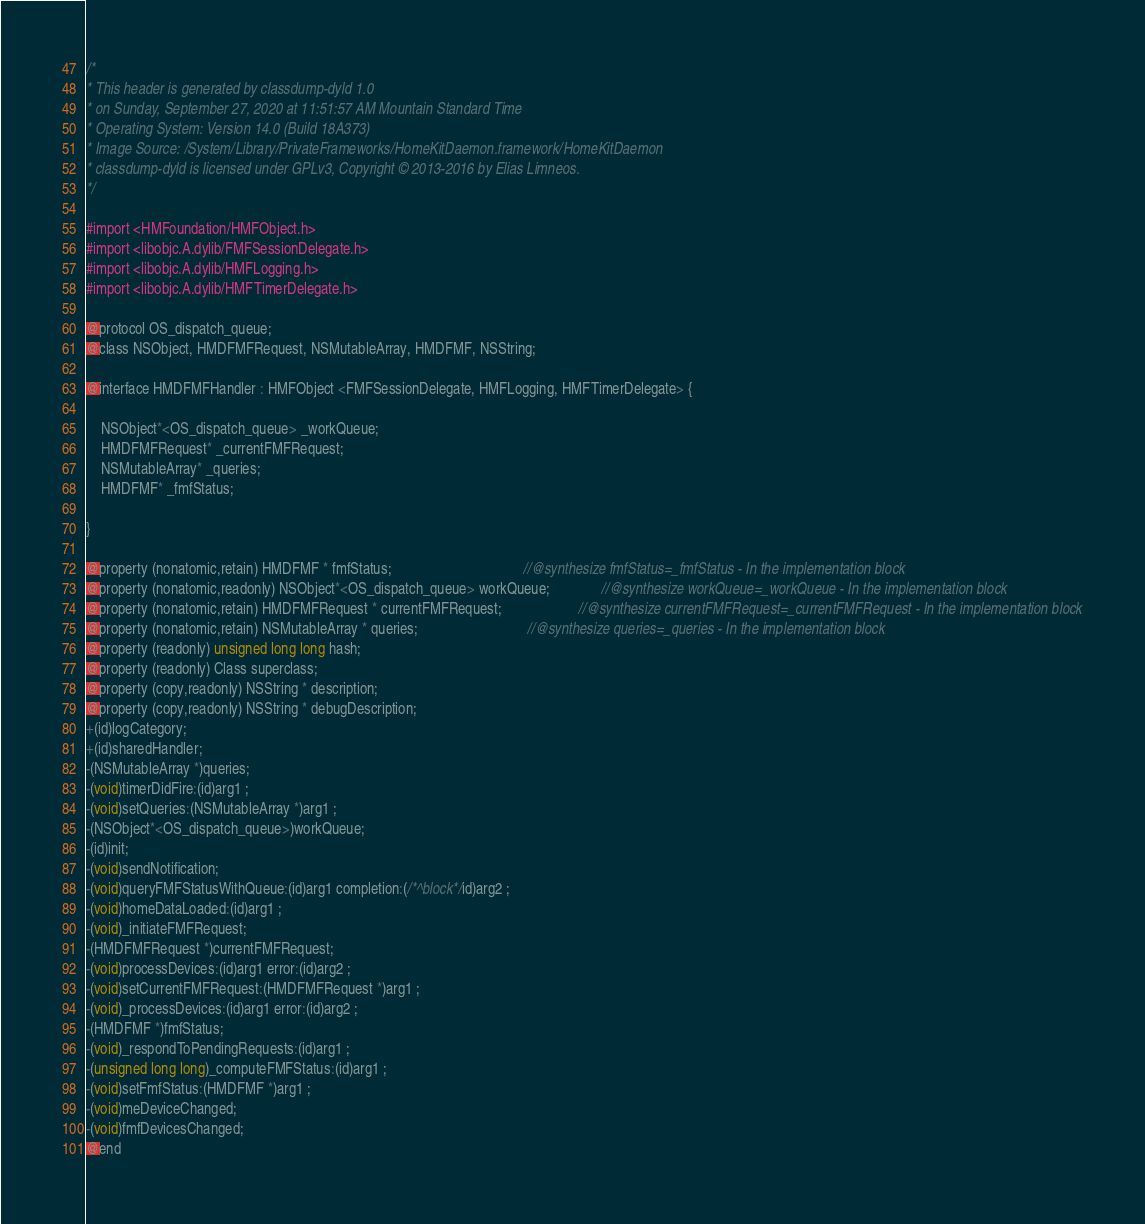<code> <loc_0><loc_0><loc_500><loc_500><_C_>/*
* This header is generated by classdump-dyld 1.0
* on Sunday, September 27, 2020 at 11:51:57 AM Mountain Standard Time
* Operating System: Version 14.0 (Build 18A373)
* Image Source: /System/Library/PrivateFrameworks/HomeKitDaemon.framework/HomeKitDaemon
* classdump-dyld is licensed under GPLv3, Copyright © 2013-2016 by Elias Limneos.
*/

#import <HMFoundation/HMFObject.h>
#import <libobjc.A.dylib/FMFSessionDelegate.h>
#import <libobjc.A.dylib/HMFLogging.h>
#import <libobjc.A.dylib/HMFTimerDelegate.h>

@protocol OS_dispatch_queue;
@class NSObject, HMDFMFRequest, NSMutableArray, HMDFMF, NSString;

@interface HMDFMFHandler : HMFObject <FMFSessionDelegate, HMFLogging, HMFTimerDelegate> {

	NSObject*<OS_dispatch_queue> _workQueue;
	HMDFMFRequest* _currentFMFRequest;
	NSMutableArray* _queries;
	HMDFMF* _fmfStatus;

}

@property (nonatomic,retain) HMDFMF * fmfStatus;                                    //@synthesize fmfStatus=_fmfStatus - In the implementation block
@property (nonatomic,readonly) NSObject*<OS_dispatch_queue> workQueue;              //@synthesize workQueue=_workQueue - In the implementation block
@property (nonatomic,retain) HMDFMFRequest * currentFMFRequest;                     //@synthesize currentFMFRequest=_currentFMFRequest - In the implementation block
@property (nonatomic,retain) NSMutableArray * queries;                              //@synthesize queries=_queries - In the implementation block
@property (readonly) unsigned long long hash; 
@property (readonly) Class superclass; 
@property (copy,readonly) NSString * description; 
@property (copy,readonly) NSString * debugDescription; 
+(id)logCategory;
+(id)sharedHandler;
-(NSMutableArray *)queries;
-(void)timerDidFire:(id)arg1 ;
-(void)setQueries:(NSMutableArray *)arg1 ;
-(NSObject*<OS_dispatch_queue>)workQueue;
-(id)init;
-(void)sendNotification;
-(void)queryFMFStatusWithQueue:(id)arg1 completion:(/*^block*/id)arg2 ;
-(void)homeDataLoaded:(id)arg1 ;
-(void)_initiateFMFRequest;
-(HMDFMFRequest *)currentFMFRequest;
-(void)processDevices:(id)arg1 error:(id)arg2 ;
-(void)setCurrentFMFRequest:(HMDFMFRequest *)arg1 ;
-(void)_processDevices:(id)arg1 error:(id)arg2 ;
-(HMDFMF *)fmfStatus;
-(void)_respondToPendingRequests:(id)arg1 ;
-(unsigned long long)_computeFMFStatus:(id)arg1 ;
-(void)setFmfStatus:(HMDFMF *)arg1 ;
-(void)meDeviceChanged;
-(void)fmfDevicesChanged;
@end

</code> 